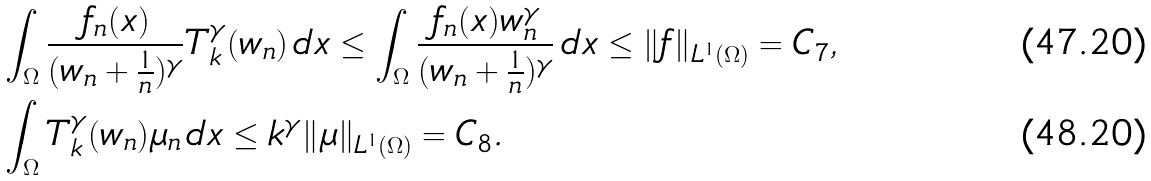Convert formula to latex. <formula><loc_0><loc_0><loc_500><loc_500>& \int _ { \Omega } \frac { f _ { n } ( x ) } { ( w _ { n } + \frac { 1 } { n } ) ^ { \gamma } } T _ { k } ^ { \gamma } ( w _ { n } ) \, d x \leq \int _ { \Omega } \frac { f _ { n } ( x ) w _ { n } ^ { \gamma } } { ( w _ { n } + \frac { 1 } { n } ) ^ { \gamma } } \, d x \leq \| f \| _ { L ^ { 1 } ( \Omega ) } = C _ { 7 } , \\ & \int _ { \Omega } T _ { k } ^ { \gamma } ( w _ { n } ) \mu _ { n } \, d x \leq k ^ { \gamma } \| \mu \| _ { L ^ { 1 } ( \Omega ) } = C _ { 8 } .</formula> 